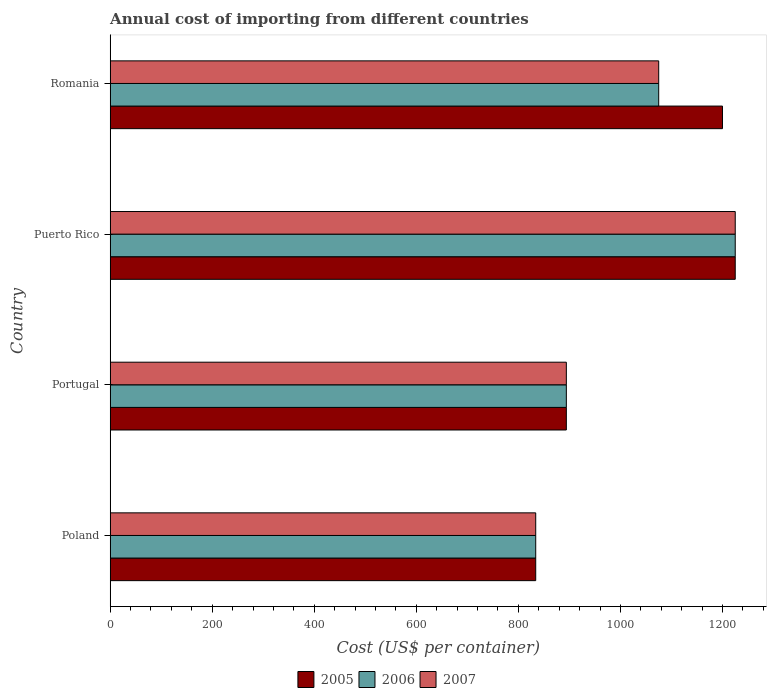How many different coloured bars are there?
Offer a terse response. 3. How many groups of bars are there?
Ensure brevity in your answer.  4. Are the number of bars per tick equal to the number of legend labels?
Ensure brevity in your answer.  Yes. Are the number of bars on each tick of the Y-axis equal?
Keep it short and to the point. Yes. How many bars are there on the 2nd tick from the top?
Your response must be concise. 3. How many bars are there on the 3rd tick from the bottom?
Ensure brevity in your answer.  3. What is the label of the 4th group of bars from the top?
Your answer should be compact. Poland. What is the total annual cost of importing in 2005 in Romania?
Make the answer very short. 1200. Across all countries, what is the maximum total annual cost of importing in 2006?
Offer a terse response. 1225. Across all countries, what is the minimum total annual cost of importing in 2007?
Your answer should be very brief. 834. In which country was the total annual cost of importing in 2006 maximum?
Provide a short and direct response. Puerto Rico. In which country was the total annual cost of importing in 2005 minimum?
Provide a short and direct response. Poland. What is the total total annual cost of importing in 2006 in the graph?
Your answer should be very brief. 4028. What is the difference between the total annual cost of importing in 2007 in Poland and that in Portugal?
Give a very brief answer. -60. What is the difference between the total annual cost of importing in 2006 in Poland and the total annual cost of importing in 2007 in Romania?
Offer a terse response. -241. What is the average total annual cost of importing in 2006 per country?
Give a very brief answer. 1007. In how many countries, is the total annual cost of importing in 2005 greater than 520 US$?
Provide a succinct answer. 4. What is the ratio of the total annual cost of importing in 2006 in Poland to that in Portugal?
Keep it short and to the point. 0.93. What is the difference between the highest and the second highest total annual cost of importing in 2007?
Your answer should be very brief. 150. What is the difference between the highest and the lowest total annual cost of importing in 2005?
Your answer should be very brief. 391. Is the sum of the total annual cost of importing in 2006 in Poland and Puerto Rico greater than the maximum total annual cost of importing in 2007 across all countries?
Offer a very short reply. Yes. What does the 3rd bar from the bottom in Portugal represents?
Your answer should be compact. 2007. Is it the case that in every country, the sum of the total annual cost of importing in 2005 and total annual cost of importing in 2007 is greater than the total annual cost of importing in 2006?
Your response must be concise. Yes. How many bars are there?
Give a very brief answer. 12. Are the values on the major ticks of X-axis written in scientific E-notation?
Your answer should be very brief. No. Does the graph contain any zero values?
Your answer should be very brief. No. Does the graph contain grids?
Your answer should be compact. No. How many legend labels are there?
Provide a short and direct response. 3. How are the legend labels stacked?
Ensure brevity in your answer.  Horizontal. What is the title of the graph?
Provide a short and direct response. Annual cost of importing from different countries. What is the label or title of the X-axis?
Keep it short and to the point. Cost (US$ per container). What is the Cost (US$ per container) in 2005 in Poland?
Your answer should be compact. 834. What is the Cost (US$ per container) of 2006 in Poland?
Offer a terse response. 834. What is the Cost (US$ per container) of 2007 in Poland?
Offer a very short reply. 834. What is the Cost (US$ per container) of 2005 in Portugal?
Offer a terse response. 894. What is the Cost (US$ per container) of 2006 in Portugal?
Offer a terse response. 894. What is the Cost (US$ per container) in 2007 in Portugal?
Your answer should be compact. 894. What is the Cost (US$ per container) of 2005 in Puerto Rico?
Offer a very short reply. 1225. What is the Cost (US$ per container) of 2006 in Puerto Rico?
Give a very brief answer. 1225. What is the Cost (US$ per container) in 2007 in Puerto Rico?
Provide a succinct answer. 1225. What is the Cost (US$ per container) in 2005 in Romania?
Keep it short and to the point. 1200. What is the Cost (US$ per container) of 2006 in Romania?
Offer a very short reply. 1075. What is the Cost (US$ per container) in 2007 in Romania?
Ensure brevity in your answer.  1075. Across all countries, what is the maximum Cost (US$ per container) in 2005?
Make the answer very short. 1225. Across all countries, what is the maximum Cost (US$ per container) of 2006?
Give a very brief answer. 1225. Across all countries, what is the maximum Cost (US$ per container) in 2007?
Offer a very short reply. 1225. Across all countries, what is the minimum Cost (US$ per container) in 2005?
Your response must be concise. 834. Across all countries, what is the minimum Cost (US$ per container) of 2006?
Give a very brief answer. 834. Across all countries, what is the minimum Cost (US$ per container) in 2007?
Provide a short and direct response. 834. What is the total Cost (US$ per container) of 2005 in the graph?
Your response must be concise. 4153. What is the total Cost (US$ per container) in 2006 in the graph?
Your response must be concise. 4028. What is the total Cost (US$ per container) in 2007 in the graph?
Offer a very short reply. 4028. What is the difference between the Cost (US$ per container) in 2005 in Poland and that in Portugal?
Keep it short and to the point. -60. What is the difference between the Cost (US$ per container) in 2006 in Poland and that in Portugal?
Make the answer very short. -60. What is the difference between the Cost (US$ per container) of 2007 in Poland and that in Portugal?
Make the answer very short. -60. What is the difference between the Cost (US$ per container) of 2005 in Poland and that in Puerto Rico?
Offer a terse response. -391. What is the difference between the Cost (US$ per container) of 2006 in Poland and that in Puerto Rico?
Make the answer very short. -391. What is the difference between the Cost (US$ per container) in 2007 in Poland and that in Puerto Rico?
Provide a short and direct response. -391. What is the difference between the Cost (US$ per container) of 2005 in Poland and that in Romania?
Make the answer very short. -366. What is the difference between the Cost (US$ per container) in 2006 in Poland and that in Romania?
Provide a succinct answer. -241. What is the difference between the Cost (US$ per container) in 2007 in Poland and that in Romania?
Provide a succinct answer. -241. What is the difference between the Cost (US$ per container) in 2005 in Portugal and that in Puerto Rico?
Offer a very short reply. -331. What is the difference between the Cost (US$ per container) in 2006 in Portugal and that in Puerto Rico?
Provide a succinct answer. -331. What is the difference between the Cost (US$ per container) of 2007 in Portugal and that in Puerto Rico?
Give a very brief answer. -331. What is the difference between the Cost (US$ per container) of 2005 in Portugal and that in Romania?
Your answer should be compact. -306. What is the difference between the Cost (US$ per container) of 2006 in Portugal and that in Romania?
Provide a short and direct response. -181. What is the difference between the Cost (US$ per container) in 2007 in Portugal and that in Romania?
Give a very brief answer. -181. What is the difference between the Cost (US$ per container) of 2006 in Puerto Rico and that in Romania?
Make the answer very short. 150. What is the difference between the Cost (US$ per container) in 2007 in Puerto Rico and that in Romania?
Make the answer very short. 150. What is the difference between the Cost (US$ per container) of 2005 in Poland and the Cost (US$ per container) of 2006 in Portugal?
Provide a short and direct response. -60. What is the difference between the Cost (US$ per container) of 2005 in Poland and the Cost (US$ per container) of 2007 in Portugal?
Ensure brevity in your answer.  -60. What is the difference between the Cost (US$ per container) in 2006 in Poland and the Cost (US$ per container) in 2007 in Portugal?
Offer a very short reply. -60. What is the difference between the Cost (US$ per container) in 2005 in Poland and the Cost (US$ per container) in 2006 in Puerto Rico?
Offer a very short reply. -391. What is the difference between the Cost (US$ per container) in 2005 in Poland and the Cost (US$ per container) in 2007 in Puerto Rico?
Your response must be concise. -391. What is the difference between the Cost (US$ per container) of 2006 in Poland and the Cost (US$ per container) of 2007 in Puerto Rico?
Your response must be concise. -391. What is the difference between the Cost (US$ per container) of 2005 in Poland and the Cost (US$ per container) of 2006 in Romania?
Offer a very short reply. -241. What is the difference between the Cost (US$ per container) in 2005 in Poland and the Cost (US$ per container) in 2007 in Romania?
Ensure brevity in your answer.  -241. What is the difference between the Cost (US$ per container) in 2006 in Poland and the Cost (US$ per container) in 2007 in Romania?
Offer a very short reply. -241. What is the difference between the Cost (US$ per container) in 2005 in Portugal and the Cost (US$ per container) in 2006 in Puerto Rico?
Your answer should be very brief. -331. What is the difference between the Cost (US$ per container) of 2005 in Portugal and the Cost (US$ per container) of 2007 in Puerto Rico?
Give a very brief answer. -331. What is the difference between the Cost (US$ per container) in 2006 in Portugal and the Cost (US$ per container) in 2007 in Puerto Rico?
Provide a succinct answer. -331. What is the difference between the Cost (US$ per container) in 2005 in Portugal and the Cost (US$ per container) in 2006 in Romania?
Offer a very short reply. -181. What is the difference between the Cost (US$ per container) in 2005 in Portugal and the Cost (US$ per container) in 2007 in Romania?
Offer a very short reply. -181. What is the difference between the Cost (US$ per container) in 2006 in Portugal and the Cost (US$ per container) in 2007 in Romania?
Give a very brief answer. -181. What is the difference between the Cost (US$ per container) of 2005 in Puerto Rico and the Cost (US$ per container) of 2006 in Romania?
Provide a short and direct response. 150. What is the difference between the Cost (US$ per container) of 2005 in Puerto Rico and the Cost (US$ per container) of 2007 in Romania?
Your answer should be very brief. 150. What is the difference between the Cost (US$ per container) in 2006 in Puerto Rico and the Cost (US$ per container) in 2007 in Romania?
Make the answer very short. 150. What is the average Cost (US$ per container) of 2005 per country?
Your answer should be compact. 1038.25. What is the average Cost (US$ per container) in 2006 per country?
Your response must be concise. 1007. What is the average Cost (US$ per container) of 2007 per country?
Give a very brief answer. 1007. What is the difference between the Cost (US$ per container) of 2005 and Cost (US$ per container) of 2006 in Poland?
Offer a terse response. 0. What is the difference between the Cost (US$ per container) in 2006 and Cost (US$ per container) in 2007 in Poland?
Provide a short and direct response. 0. What is the difference between the Cost (US$ per container) of 2005 and Cost (US$ per container) of 2007 in Portugal?
Your answer should be compact. 0. What is the difference between the Cost (US$ per container) of 2006 and Cost (US$ per container) of 2007 in Portugal?
Provide a short and direct response. 0. What is the difference between the Cost (US$ per container) of 2006 and Cost (US$ per container) of 2007 in Puerto Rico?
Offer a very short reply. 0. What is the difference between the Cost (US$ per container) in 2005 and Cost (US$ per container) in 2006 in Romania?
Provide a short and direct response. 125. What is the difference between the Cost (US$ per container) in 2005 and Cost (US$ per container) in 2007 in Romania?
Your answer should be very brief. 125. What is the ratio of the Cost (US$ per container) in 2005 in Poland to that in Portugal?
Provide a short and direct response. 0.93. What is the ratio of the Cost (US$ per container) in 2006 in Poland to that in Portugal?
Your answer should be very brief. 0.93. What is the ratio of the Cost (US$ per container) in 2007 in Poland to that in Portugal?
Your answer should be very brief. 0.93. What is the ratio of the Cost (US$ per container) of 2005 in Poland to that in Puerto Rico?
Give a very brief answer. 0.68. What is the ratio of the Cost (US$ per container) of 2006 in Poland to that in Puerto Rico?
Provide a short and direct response. 0.68. What is the ratio of the Cost (US$ per container) in 2007 in Poland to that in Puerto Rico?
Your answer should be compact. 0.68. What is the ratio of the Cost (US$ per container) in 2005 in Poland to that in Romania?
Your response must be concise. 0.69. What is the ratio of the Cost (US$ per container) in 2006 in Poland to that in Romania?
Provide a short and direct response. 0.78. What is the ratio of the Cost (US$ per container) in 2007 in Poland to that in Romania?
Your answer should be compact. 0.78. What is the ratio of the Cost (US$ per container) in 2005 in Portugal to that in Puerto Rico?
Your answer should be very brief. 0.73. What is the ratio of the Cost (US$ per container) of 2006 in Portugal to that in Puerto Rico?
Give a very brief answer. 0.73. What is the ratio of the Cost (US$ per container) of 2007 in Portugal to that in Puerto Rico?
Your response must be concise. 0.73. What is the ratio of the Cost (US$ per container) of 2005 in Portugal to that in Romania?
Provide a short and direct response. 0.74. What is the ratio of the Cost (US$ per container) of 2006 in Portugal to that in Romania?
Keep it short and to the point. 0.83. What is the ratio of the Cost (US$ per container) of 2007 in Portugal to that in Romania?
Provide a succinct answer. 0.83. What is the ratio of the Cost (US$ per container) of 2005 in Puerto Rico to that in Romania?
Offer a very short reply. 1.02. What is the ratio of the Cost (US$ per container) of 2006 in Puerto Rico to that in Romania?
Keep it short and to the point. 1.14. What is the ratio of the Cost (US$ per container) in 2007 in Puerto Rico to that in Romania?
Your response must be concise. 1.14. What is the difference between the highest and the second highest Cost (US$ per container) of 2006?
Offer a very short reply. 150. What is the difference between the highest and the second highest Cost (US$ per container) of 2007?
Give a very brief answer. 150. What is the difference between the highest and the lowest Cost (US$ per container) of 2005?
Offer a very short reply. 391. What is the difference between the highest and the lowest Cost (US$ per container) of 2006?
Offer a very short reply. 391. What is the difference between the highest and the lowest Cost (US$ per container) of 2007?
Your answer should be very brief. 391. 